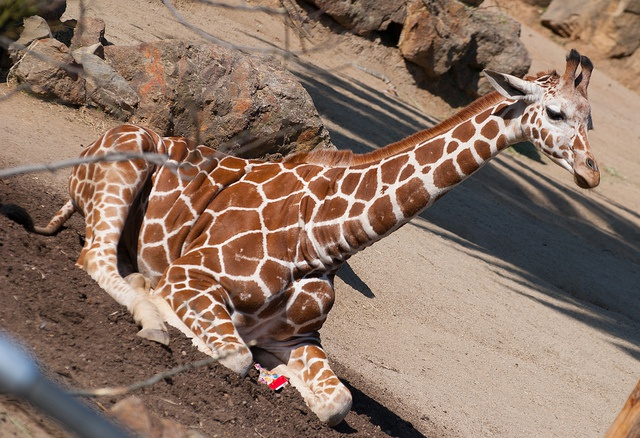Describe the objects in this image and their specific colors. I can see a giraffe in gray, brown, lightgray, and maroon tones in this image. 